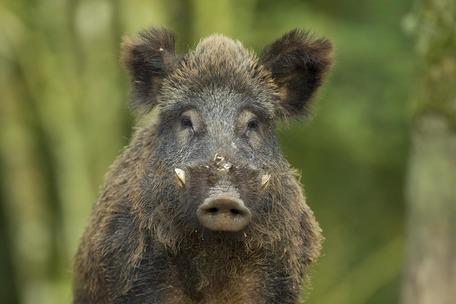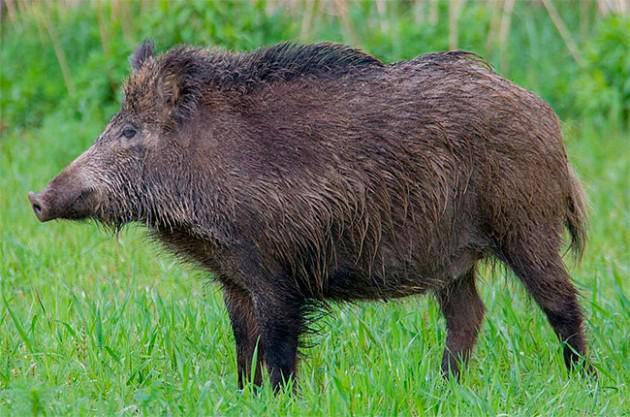The first image is the image on the left, the second image is the image on the right. Evaluate the accuracy of this statement regarding the images: "The pig in the image on the left is facing the camera.". Is it true? Answer yes or no. Yes. The first image is the image on the left, the second image is the image on the right. For the images displayed, is the sentence "One image shows a single wild pig with its head and body facing forward, and the other image shows a single standing wild pig with its head and body in profile." factually correct? Answer yes or no. Yes. 